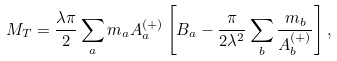<formula> <loc_0><loc_0><loc_500><loc_500>M _ { T } = \frac { \lambda \pi } { 2 } \sum _ { a } m _ { a } A _ { a } ^ { ( + ) } \left [ B _ { a } - \frac { \pi } { 2 \lambda ^ { 2 } } \sum _ { b } \frac { m _ { b } } { A _ { b } ^ { ( + ) } } \right ] ,</formula> 